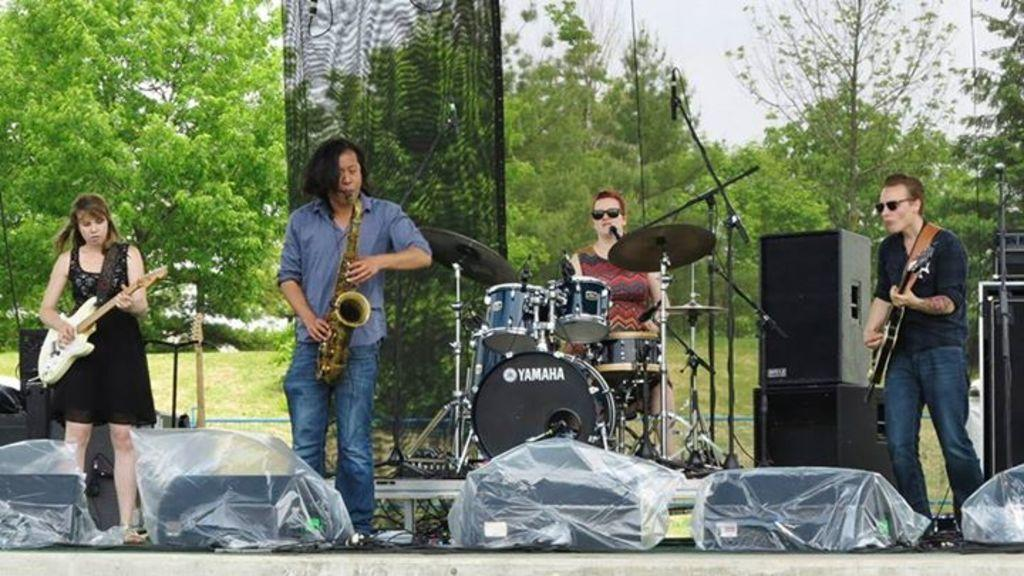How many people are present in the image? There are four people in the image. What are the people doing in the image? The people are playing musical instruments. What can be seen in the background of the image? There are trees visible in the background of the image. What type of copper items can be seen in the image? There is no copper present in the image. How many things are visible in the image? It is not possible to determine the exact number of things visible in the image without more specific information. 